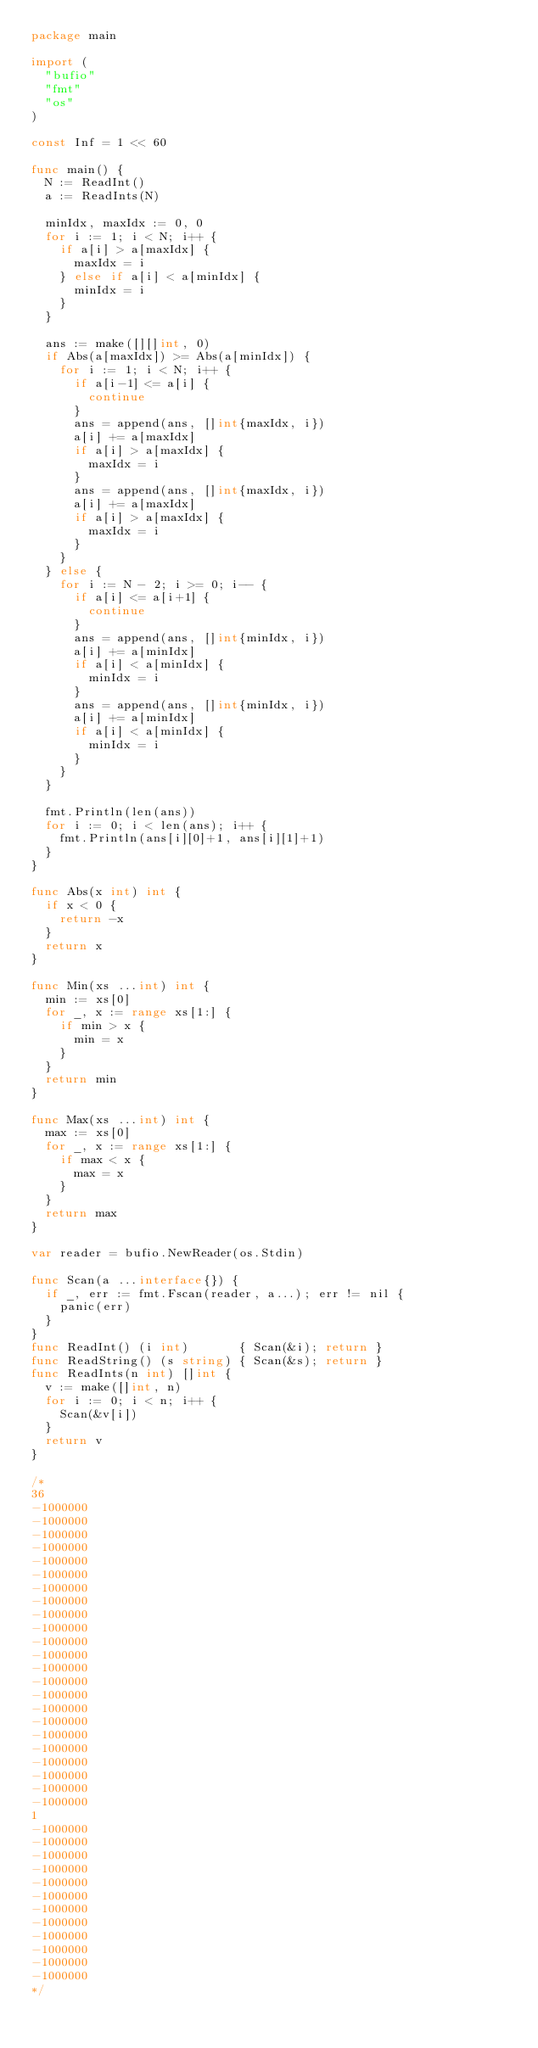Convert code to text. <code><loc_0><loc_0><loc_500><loc_500><_Go_>package main

import (
	"bufio"
	"fmt"
	"os"
)

const Inf = 1 << 60

func main() {
	N := ReadInt()
	a := ReadInts(N)

	minIdx, maxIdx := 0, 0
	for i := 1; i < N; i++ {
		if a[i] > a[maxIdx] {
			maxIdx = i
		} else if a[i] < a[minIdx] {
			minIdx = i
		}
	}

	ans := make([][]int, 0)
	if Abs(a[maxIdx]) >= Abs(a[minIdx]) {
		for i := 1; i < N; i++ {
			if a[i-1] <= a[i] {
				continue
			}
			ans = append(ans, []int{maxIdx, i})
			a[i] += a[maxIdx]
			if a[i] > a[maxIdx] {
				maxIdx = i
			}
			ans = append(ans, []int{maxIdx, i})
			a[i] += a[maxIdx]
			if a[i] > a[maxIdx] {
				maxIdx = i
			}
		}
	} else {
		for i := N - 2; i >= 0; i-- {
			if a[i] <= a[i+1] {
				continue
			}
			ans = append(ans, []int{minIdx, i})
			a[i] += a[minIdx]
			if a[i] < a[minIdx] {
				minIdx = i
			}
			ans = append(ans, []int{minIdx, i})
			a[i] += a[minIdx]
			if a[i] < a[minIdx] {
				minIdx = i
			}
		}
	}

	fmt.Println(len(ans))
	for i := 0; i < len(ans); i++ {
		fmt.Println(ans[i][0]+1, ans[i][1]+1)
	}
}

func Abs(x int) int {
	if x < 0 {
		return -x
	}
	return x
}

func Min(xs ...int) int {
	min := xs[0]
	for _, x := range xs[1:] {
		if min > x {
			min = x
		}
	}
	return min
}

func Max(xs ...int) int {
	max := xs[0]
	for _, x := range xs[1:] {
		if max < x {
			max = x
		}
	}
	return max
}

var reader = bufio.NewReader(os.Stdin)

func Scan(a ...interface{}) {
	if _, err := fmt.Fscan(reader, a...); err != nil {
		panic(err)
	}
}
func ReadInt() (i int)       { Scan(&i); return }
func ReadString() (s string) { Scan(&s); return }
func ReadInts(n int) []int {
	v := make([]int, n)
	for i := 0; i < n; i++ {
		Scan(&v[i])
	}
	return v
}

/*
36
-1000000
-1000000
-1000000
-1000000
-1000000
-1000000
-1000000
-1000000
-1000000
-1000000
-1000000
-1000000
-1000000
-1000000
-1000000
-1000000
-1000000
-1000000
-1000000
-1000000
-1000000
-1000000
-1000000
1
-1000000
-1000000
-1000000
-1000000
-1000000
-1000000
-1000000
-1000000
-1000000
-1000000
-1000000
-1000000
*/
</code> 